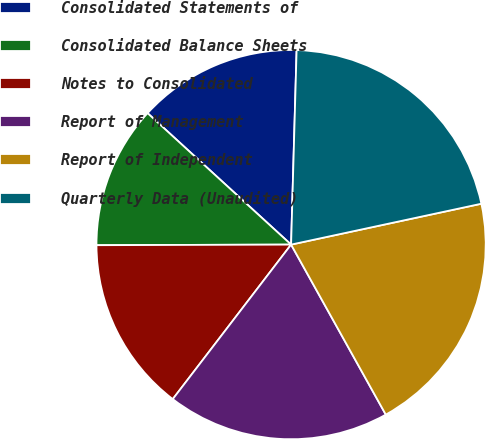Convert chart. <chart><loc_0><loc_0><loc_500><loc_500><pie_chart><fcel>Consolidated Statements of<fcel>Consolidated Balance Sheets<fcel>Notes to Consolidated<fcel>Report of Management<fcel>Report of Independent<fcel>Quarterly Data (Unaudited)<nl><fcel>13.65%<fcel>11.85%<fcel>14.55%<fcel>18.49%<fcel>20.28%<fcel>21.18%<nl></chart> 